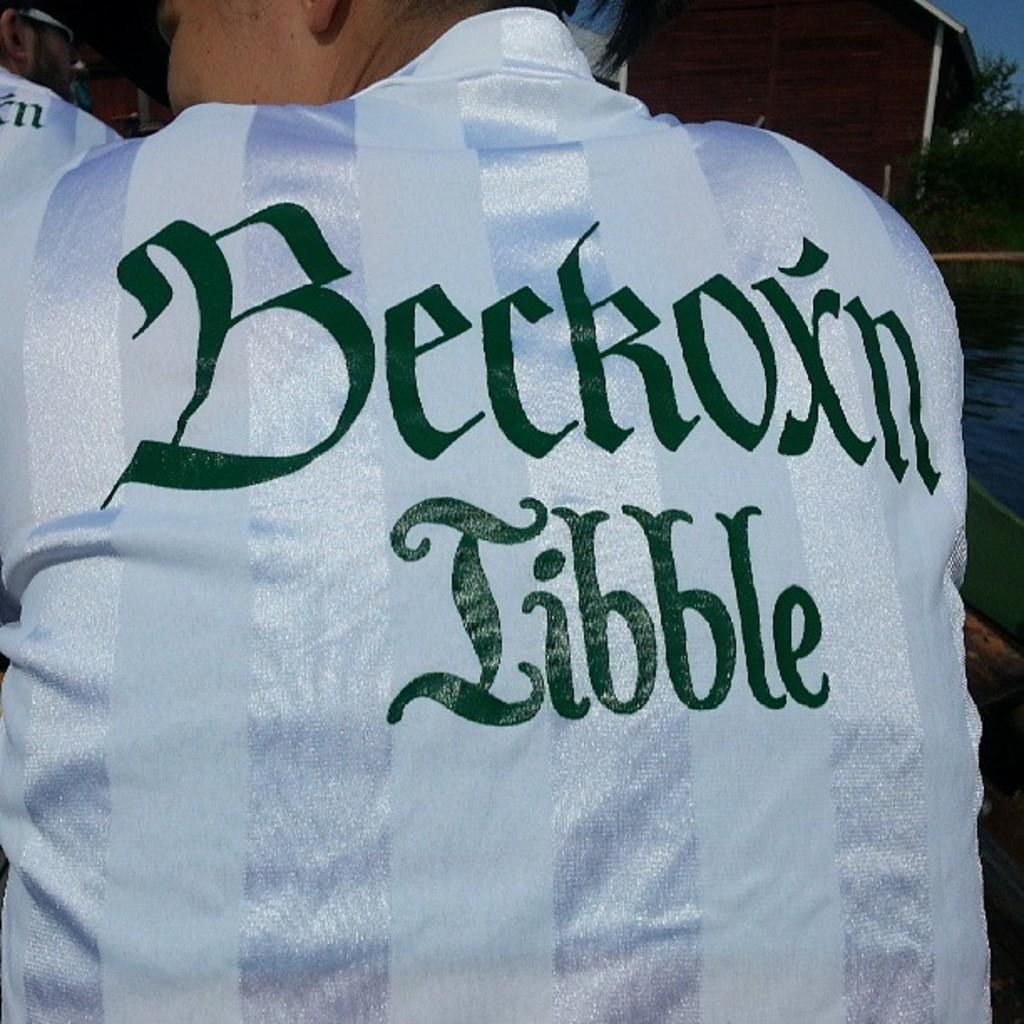<image>
Write a terse but informative summary of the picture. A white shirt says "Beckoxn Libble" in green text. 